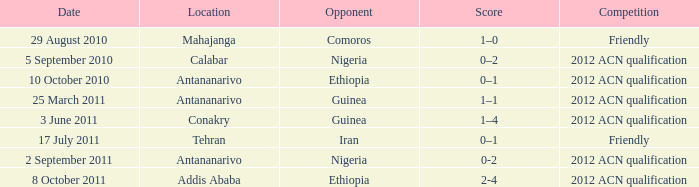What is the total at the addis ababa place? 2-4. 